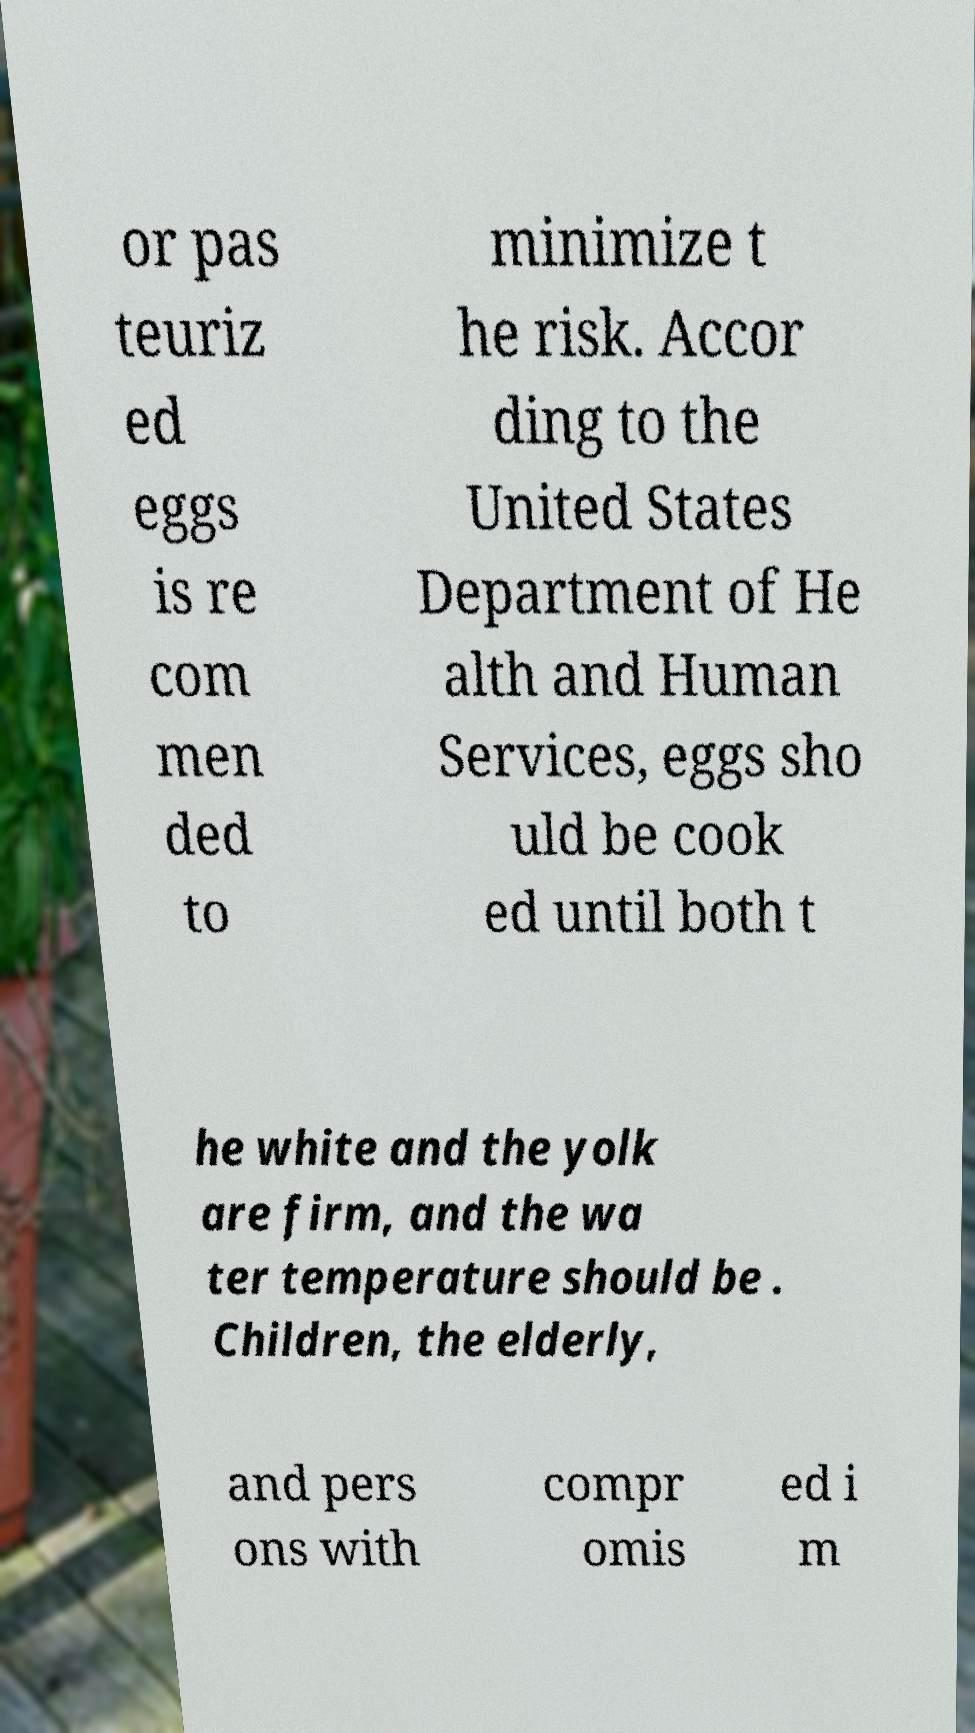Could you extract and type out the text from this image? or pas teuriz ed eggs is re com men ded to minimize t he risk. Accor ding to the United States Department of He alth and Human Services, eggs sho uld be cook ed until both t he white and the yolk are firm, and the wa ter temperature should be . Children, the elderly, and pers ons with compr omis ed i m 